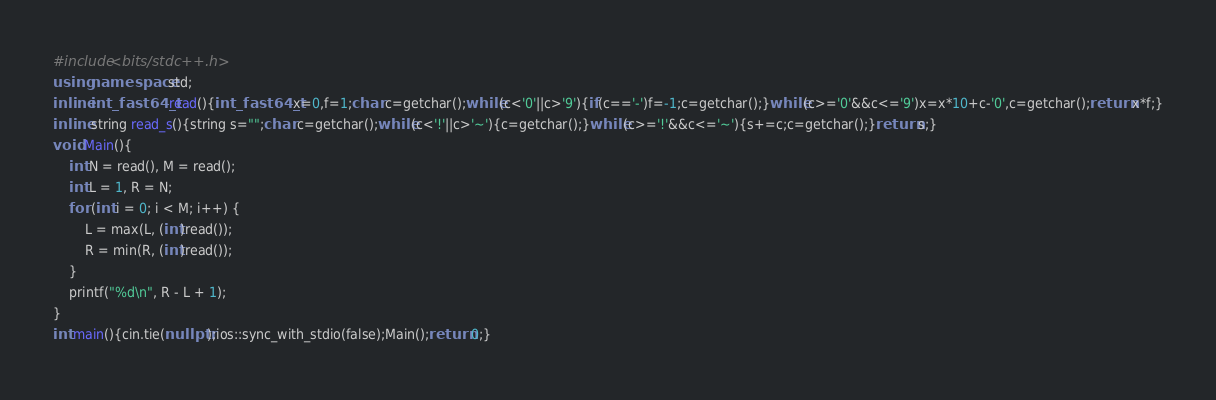Convert code to text. <code><loc_0><loc_0><loc_500><loc_500><_C++_>#include<bits/stdc++.h>
using namespace std;
inline int_fast64_t read(){int_fast64_t x=0,f=1;char c=getchar();while(c<'0'||c>'9'){if(c=='-')f=-1;c=getchar();}while(c>='0'&&c<='9')x=x*10+c-'0',c=getchar();return x*f;}
inline string read_s(){string s="";char c=getchar();while(c<'!'||c>'~'){c=getchar();}while(c>='!'&&c<='~'){s+=c;c=getchar();}return s;}
void Main(){
    int N = read(), M = read();
    int L = 1, R = N;
    for (int i = 0; i < M; i++) {
        L = max(L, (int)read());
        R = min(R, (int)read());
    }
    printf("%d\n", R - L + 1);
}
int main(){cin.tie(nullptr);ios::sync_with_stdio(false);Main();return 0;}</code> 